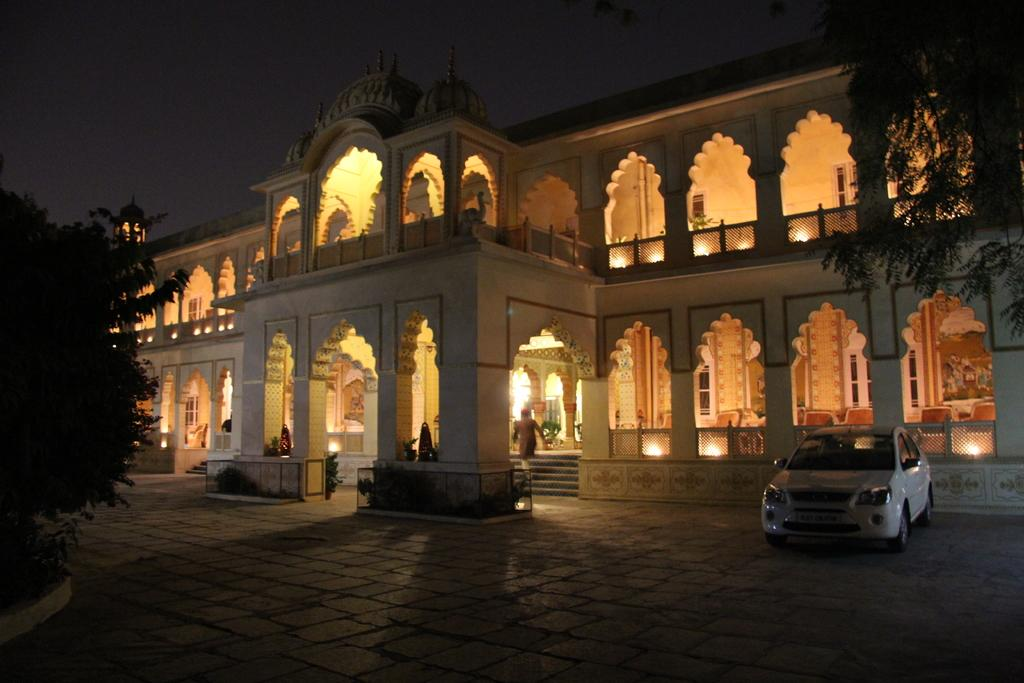What is in the foreground of the image? There is a pavement in the foreground of the image. What can be seen on both sides of the image? There are trees on the left and right sides of the image. What is visible in the background of the image? There is a car, a building, lights, and a dark sky visible in the background of the image. Can you see any snails smashing into the building in the image? There are no snails or any indication of them smashing into the building in the image. Is there a boat visible in the image? There is no boat present in the image. 